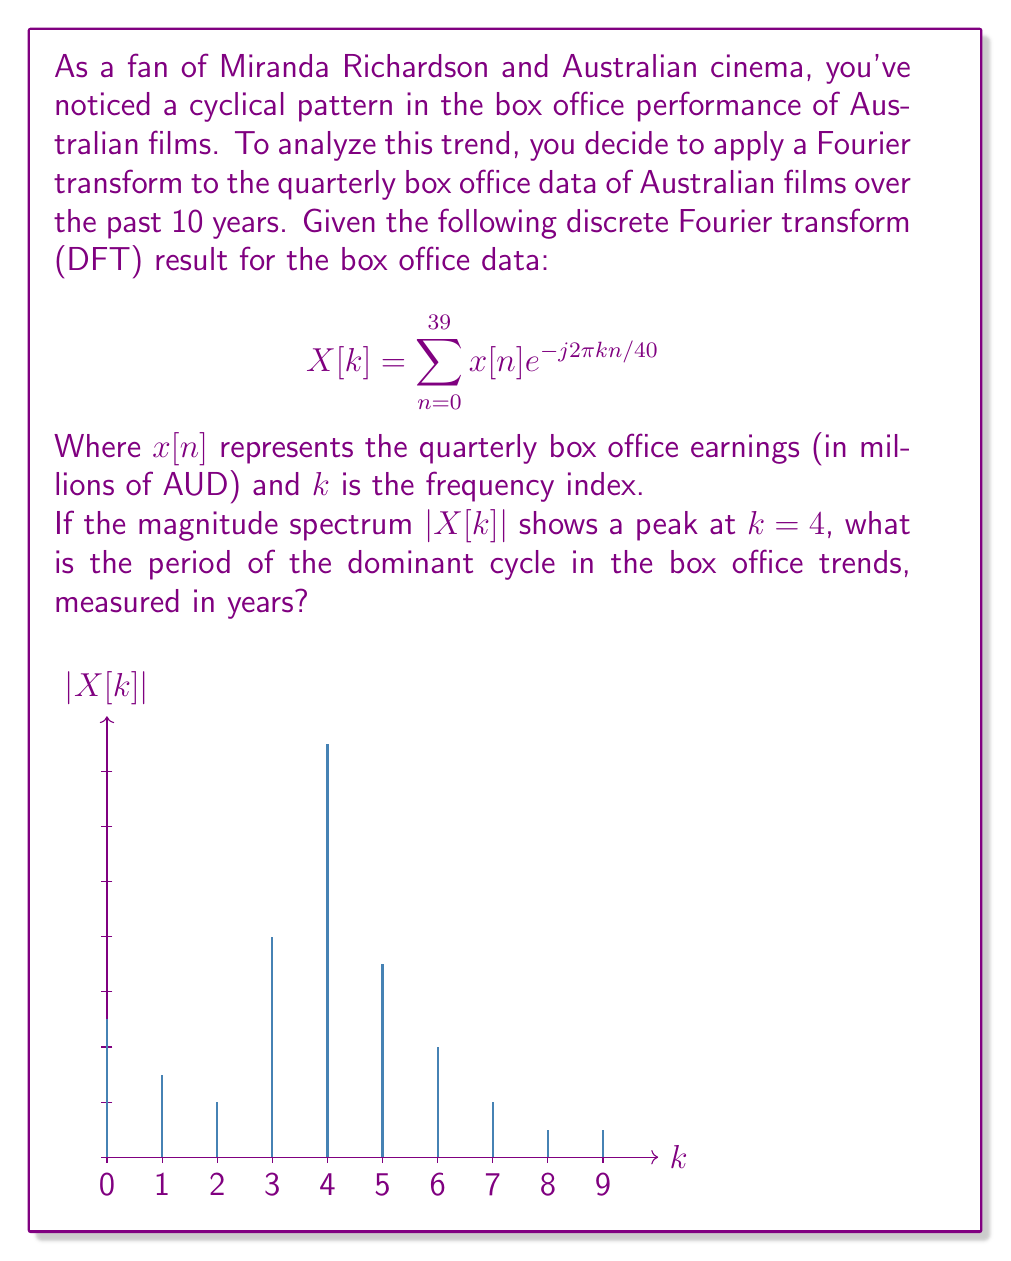Show me your answer to this math problem. Let's approach this step-by-step:

1) In the DFT, the frequency index $k$ corresponds to the number of cycles completed over the entire data set.

2) We're given that the data spans 10 years, with quarterly measurements. This means we have 40 data points in total (4 quarters per year × 10 years).

3) The peak at $k=4$ indicates that the dominant frequency completes 4 cycles over the entire 40-point data set.

4) To find the period, we need to determine how long it takes to complete one cycle. We can do this by dividing the total time span by the number of cycles:

   $$\text{Period} = \frac{\text{Total time}}{\text{Number of cycles}} = \frac{10 \text{ years}}{4}$$

5) Simplifying this fraction:

   $$\text{Period} = 2.5 \text{ years}$$

Therefore, the dominant cycle in the box office trends has a period of 2.5 years.
Answer: 2.5 years 